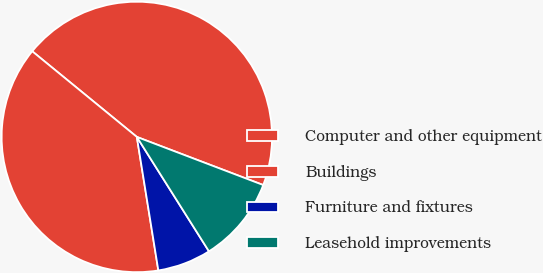<chart> <loc_0><loc_0><loc_500><loc_500><pie_chart><fcel>Computer and other equipment<fcel>Buildings<fcel>Furniture and fixtures<fcel>Leasehold improvements<nl><fcel>44.87%<fcel>38.46%<fcel>6.41%<fcel>10.26%<nl></chart> 